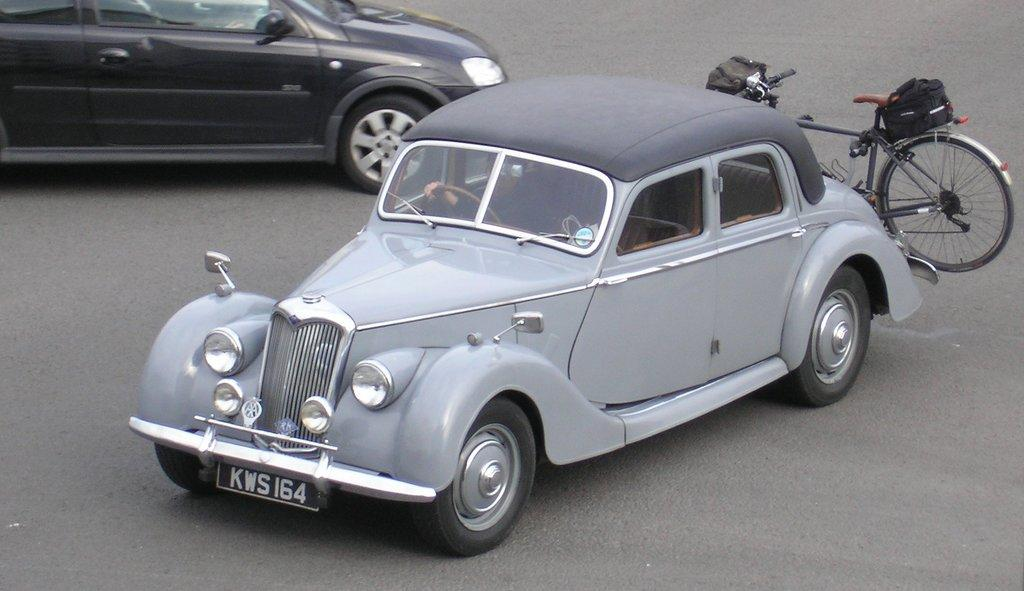What type of vehicles are in the image? There are cars in the image. What other mode of transportation can be seen in the image? There is a bicycle in the image. Where are the cars and the bicycle located? Both the cars and the bicycle are on the road. What color is the silver whistle that the pigs are using in the image? There is no silver whistle or pigs present in the image. 